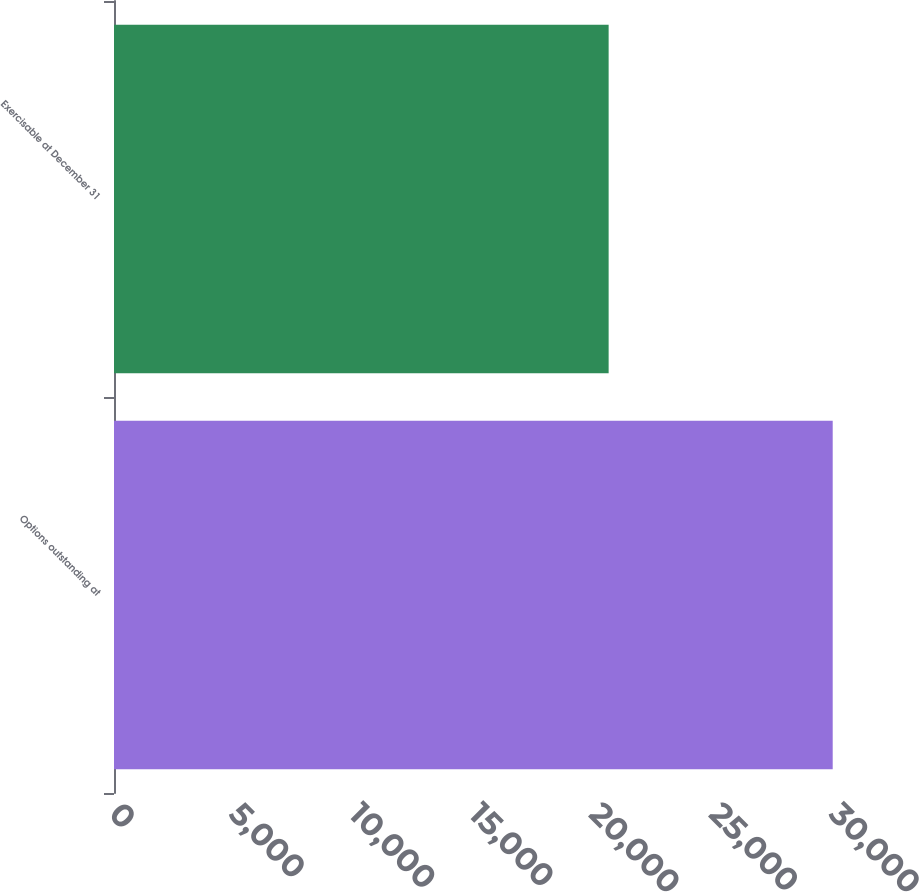Convert chart to OTSL. <chart><loc_0><loc_0><loc_500><loc_500><bar_chart><fcel>Options outstanding at<fcel>Exercisable at December 31<nl><fcel>29946<fcel>20610<nl></chart> 